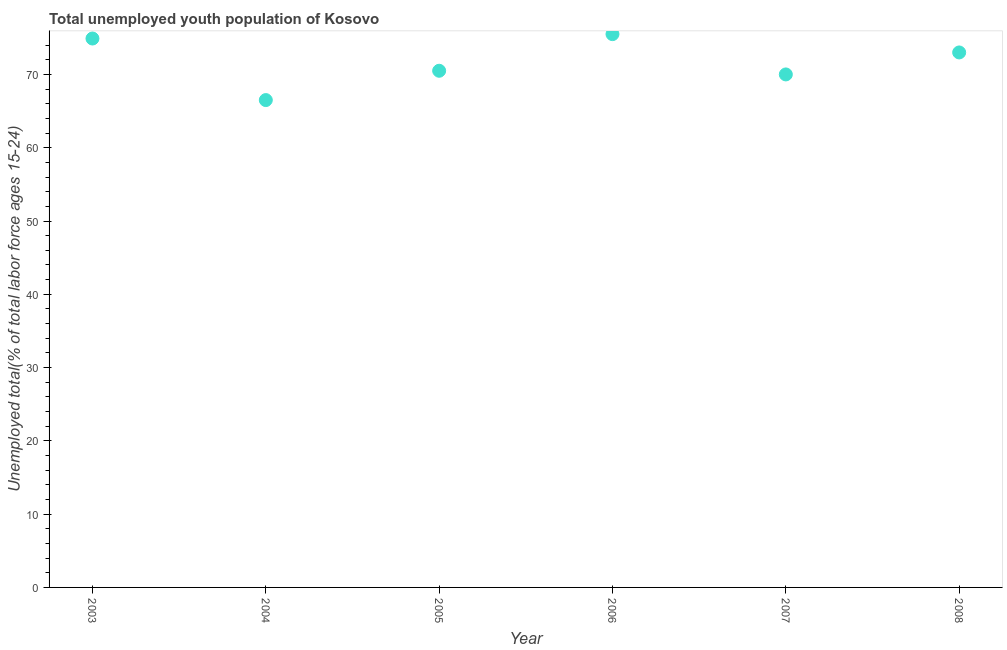What is the unemployed youth in 2003?
Provide a succinct answer. 74.9. Across all years, what is the maximum unemployed youth?
Ensure brevity in your answer.  75.5. Across all years, what is the minimum unemployed youth?
Offer a very short reply. 66.5. In which year was the unemployed youth minimum?
Ensure brevity in your answer.  2004. What is the sum of the unemployed youth?
Provide a succinct answer. 430.4. What is the difference between the unemployed youth in 2003 and 2006?
Your answer should be compact. -0.6. What is the average unemployed youth per year?
Make the answer very short. 71.73. What is the median unemployed youth?
Offer a terse response. 71.75. What is the ratio of the unemployed youth in 2005 to that in 2007?
Your response must be concise. 1.01. Is the unemployed youth in 2003 less than that in 2005?
Offer a very short reply. No. Is the difference between the unemployed youth in 2006 and 2008 greater than the difference between any two years?
Ensure brevity in your answer.  No. What is the difference between the highest and the second highest unemployed youth?
Keep it short and to the point. 0.6. What is the difference between the highest and the lowest unemployed youth?
Offer a terse response. 9. In how many years, is the unemployed youth greater than the average unemployed youth taken over all years?
Your response must be concise. 3. Does the unemployed youth monotonically increase over the years?
Provide a succinct answer. No. Are the values on the major ticks of Y-axis written in scientific E-notation?
Give a very brief answer. No. Does the graph contain any zero values?
Keep it short and to the point. No. Does the graph contain grids?
Your answer should be very brief. No. What is the title of the graph?
Ensure brevity in your answer.  Total unemployed youth population of Kosovo. What is the label or title of the X-axis?
Your answer should be compact. Year. What is the label or title of the Y-axis?
Offer a terse response. Unemployed total(% of total labor force ages 15-24). What is the Unemployed total(% of total labor force ages 15-24) in 2003?
Your response must be concise. 74.9. What is the Unemployed total(% of total labor force ages 15-24) in 2004?
Your answer should be compact. 66.5. What is the Unemployed total(% of total labor force ages 15-24) in 2005?
Your response must be concise. 70.5. What is the Unemployed total(% of total labor force ages 15-24) in 2006?
Give a very brief answer. 75.5. What is the difference between the Unemployed total(% of total labor force ages 15-24) in 2003 and 2004?
Give a very brief answer. 8.4. What is the difference between the Unemployed total(% of total labor force ages 15-24) in 2003 and 2008?
Provide a succinct answer. 1.9. What is the difference between the Unemployed total(% of total labor force ages 15-24) in 2004 and 2006?
Your answer should be very brief. -9. What is the difference between the Unemployed total(% of total labor force ages 15-24) in 2004 and 2007?
Ensure brevity in your answer.  -3.5. What is the difference between the Unemployed total(% of total labor force ages 15-24) in 2006 and 2007?
Your answer should be very brief. 5.5. What is the difference between the Unemployed total(% of total labor force ages 15-24) in 2007 and 2008?
Your answer should be compact. -3. What is the ratio of the Unemployed total(% of total labor force ages 15-24) in 2003 to that in 2004?
Offer a terse response. 1.13. What is the ratio of the Unemployed total(% of total labor force ages 15-24) in 2003 to that in 2005?
Provide a succinct answer. 1.06. What is the ratio of the Unemployed total(% of total labor force ages 15-24) in 2003 to that in 2007?
Make the answer very short. 1.07. What is the ratio of the Unemployed total(% of total labor force ages 15-24) in 2004 to that in 2005?
Provide a short and direct response. 0.94. What is the ratio of the Unemployed total(% of total labor force ages 15-24) in 2004 to that in 2006?
Provide a short and direct response. 0.88. What is the ratio of the Unemployed total(% of total labor force ages 15-24) in 2004 to that in 2007?
Your answer should be compact. 0.95. What is the ratio of the Unemployed total(% of total labor force ages 15-24) in 2004 to that in 2008?
Your answer should be compact. 0.91. What is the ratio of the Unemployed total(% of total labor force ages 15-24) in 2005 to that in 2006?
Your response must be concise. 0.93. What is the ratio of the Unemployed total(% of total labor force ages 15-24) in 2005 to that in 2007?
Provide a short and direct response. 1.01. What is the ratio of the Unemployed total(% of total labor force ages 15-24) in 2006 to that in 2007?
Make the answer very short. 1.08. What is the ratio of the Unemployed total(% of total labor force ages 15-24) in 2006 to that in 2008?
Keep it short and to the point. 1.03. What is the ratio of the Unemployed total(% of total labor force ages 15-24) in 2007 to that in 2008?
Your response must be concise. 0.96. 